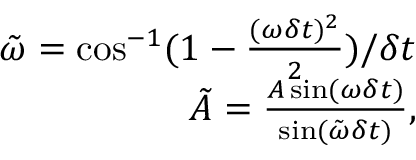Convert formula to latex. <formula><loc_0><loc_0><loc_500><loc_500>\begin{array} { r } { \tilde { \omega } = \cos ^ { - 1 } ( 1 - \frac { ( \omega \delta t ) ^ { 2 } } { 2 } ) / \delta t } \\ { \tilde { A } = \frac { A \sin ( \omega \delta t ) } { \sin ( \tilde { \omega } \delta t ) } , } \end{array}</formula> 